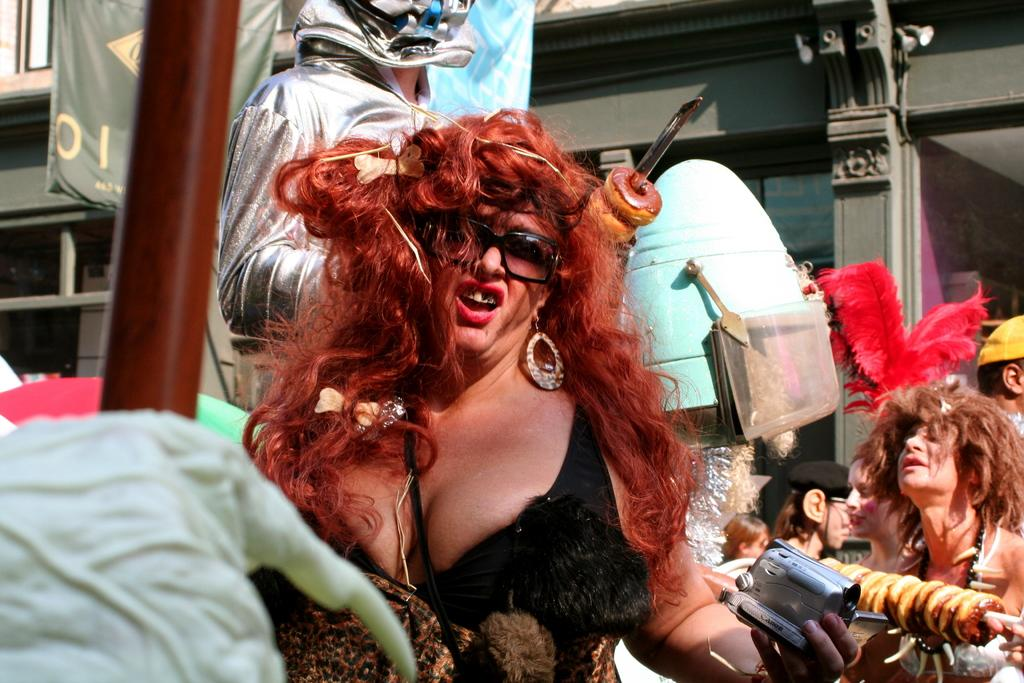Who is the main subject in the image? There is a lady in the image. What is a distinctive feature of the lady's appearance? The lady's hair is in red color. What can be seen in the background of the image? There are many people in the background of the image. What type of board is the lady using to laugh in the image? There is no board or laughter depicted in the image; it only shows a lady with red hair. 